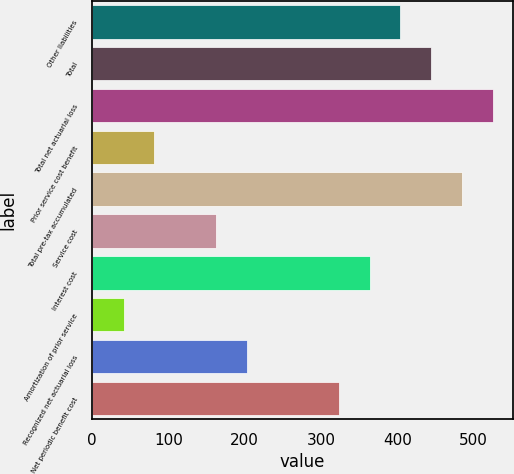<chart> <loc_0><loc_0><loc_500><loc_500><bar_chart><fcel>Other liabilities<fcel>Total<fcel>Total net actuarial loss<fcel>Prior service cost benefit<fcel>Total pre-tax accumulated<fcel>Service cost<fcel>Interest cost<fcel>Amortization of prior service<fcel>Recognized net actuarial loss<fcel>Net periodic benefit cost<nl><fcel>404.1<fcel>444.43<fcel>525.09<fcel>81.46<fcel>484.76<fcel>162.12<fcel>363.77<fcel>41.13<fcel>202.45<fcel>323.44<nl></chart> 